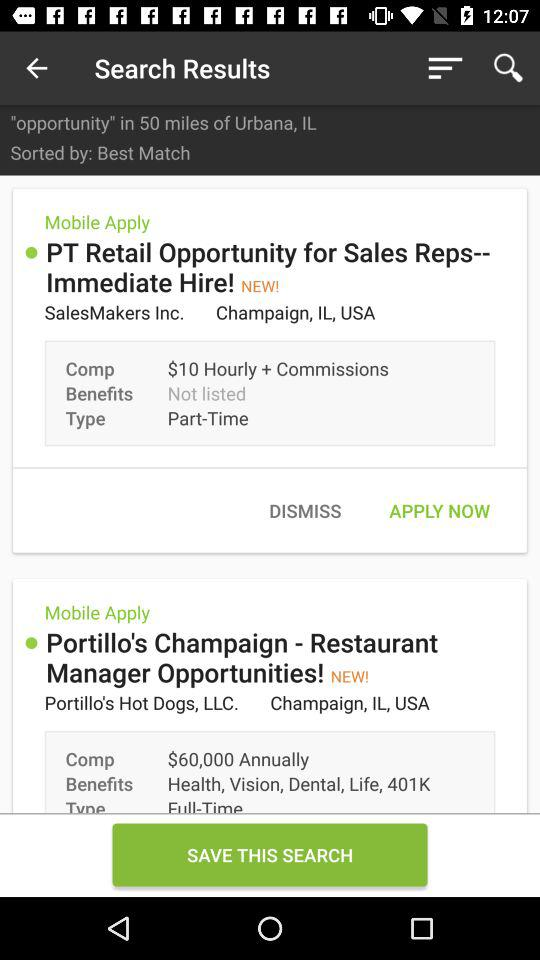What benefits will one get after being selected as a restaurant manager? One will get health, vision, dental, life and 401K benefits after being selected as a restaurant manager. 